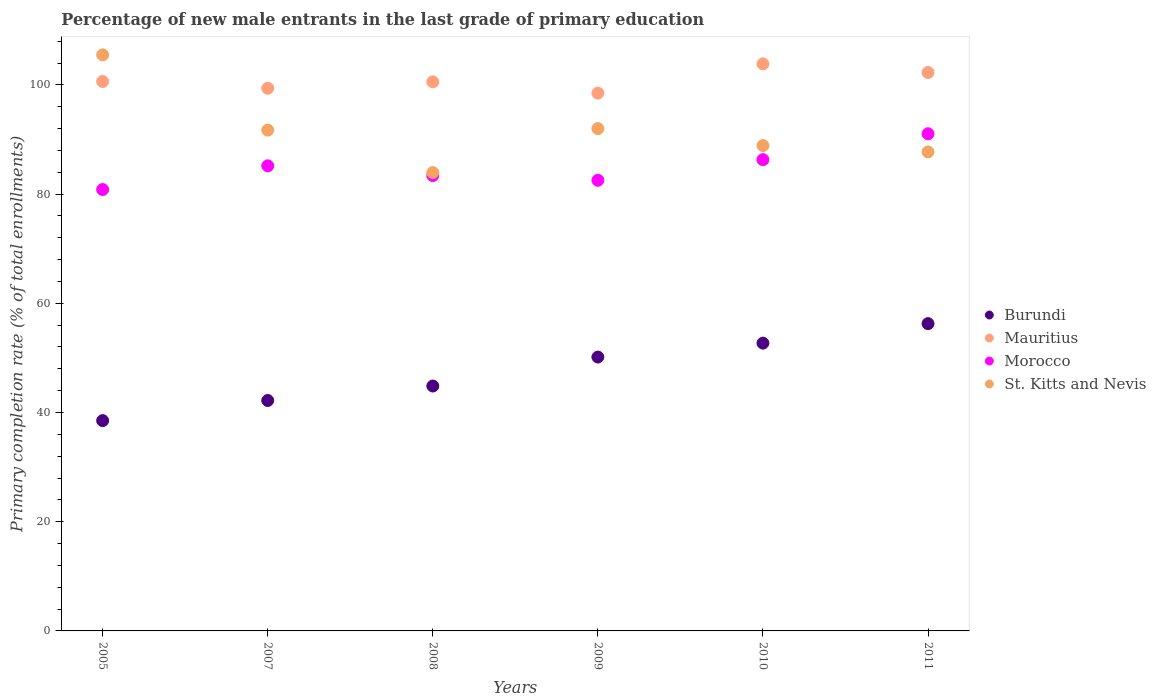Is the number of dotlines equal to the number of legend labels?
Keep it short and to the point. Yes. What is the percentage of new male entrants in Morocco in 2009?
Your answer should be very brief. 82.53. Across all years, what is the maximum percentage of new male entrants in St. Kitts and Nevis?
Offer a terse response. 105.5. Across all years, what is the minimum percentage of new male entrants in Burundi?
Give a very brief answer. 38.52. In which year was the percentage of new male entrants in Morocco minimum?
Ensure brevity in your answer.  2005. What is the total percentage of new male entrants in St. Kitts and Nevis in the graph?
Ensure brevity in your answer.  549.79. What is the difference between the percentage of new male entrants in Mauritius in 2005 and that in 2008?
Provide a short and direct response. 0.06. What is the difference between the percentage of new male entrants in Morocco in 2009 and the percentage of new male entrants in Mauritius in 2007?
Offer a very short reply. -16.86. What is the average percentage of new male entrants in Mauritius per year?
Your answer should be compact. 100.87. In the year 2011, what is the difference between the percentage of new male entrants in Morocco and percentage of new male entrants in Mauritius?
Offer a terse response. -11.22. In how many years, is the percentage of new male entrants in Mauritius greater than 44 %?
Provide a succinct answer. 6. What is the ratio of the percentage of new male entrants in Burundi in 2008 to that in 2011?
Keep it short and to the point. 0.8. Is the percentage of new male entrants in Burundi in 2005 less than that in 2011?
Provide a succinct answer. Yes. What is the difference between the highest and the second highest percentage of new male entrants in Mauritius?
Provide a succinct answer. 1.58. What is the difference between the highest and the lowest percentage of new male entrants in St. Kitts and Nevis?
Offer a very short reply. 21.56. In how many years, is the percentage of new male entrants in Burundi greater than the average percentage of new male entrants in Burundi taken over all years?
Your response must be concise. 3. Is it the case that in every year, the sum of the percentage of new male entrants in Morocco and percentage of new male entrants in St. Kitts and Nevis  is greater than the percentage of new male entrants in Mauritius?
Give a very brief answer. Yes. How many dotlines are there?
Provide a short and direct response. 4. How many years are there in the graph?
Provide a short and direct response. 6. Are the values on the major ticks of Y-axis written in scientific E-notation?
Your response must be concise. No. Does the graph contain any zero values?
Offer a very short reply. No. Does the graph contain grids?
Offer a terse response. No. Where does the legend appear in the graph?
Offer a terse response. Center right. What is the title of the graph?
Offer a terse response. Percentage of new male entrants in the last grade of primary education. Does "South Africa" appear as one of the legend labels in the graph?
Provide a succinct answer. No. What is the label or title of the X-axis?
Your answer should be compact. Years. What is the label or title of the Y-axis?
Your answer should be very brief. Primary completion rate (% of total enrollments). What is the Primary completion rate (% of total enrollments) in Burundi in 2005?
Your response must be concise. 38.52. What is the Primary completion rate (% of total enrollments) of Mauritius in 2005?
Provide a short and direct response. 100.62. What is the Primary completion rate (% of total enrollments) of Morocco in 2005?
Provide a succinct answer. 80.83. What is the Primary completion rate (% of total enrollments) of St. Kitts and Nevis in 2005?
Offer a terse response. 105.5. What is the Primary completion rate (% of total enrollments) in Burundi in 2007?
Your response must be concise. 42.21. What is the Primary completion rate (% of total enrollments) of Mauritius in 2007?
Provide a succinct answer. 99.39. What is the Primary completion rate (% of total enrollments) in Morocco in 2007?
Your answer should be compact. 85.18. What is the Primary completion rate (% of total enrollments) of St. Kitts and Nevis in 2007?
Your answer should be very brief. 91.72. What is the Primary completion rate (% of total enrollments) in Burundi in 2008?
Make the answer very short. 44.85. What is the Primary completion rate (% of total enrollments) of Mauritius in 2008?
Your answer should be very brief. 100.57. What is the Primary completion rate (% of total enrollments) in Morocco in 2008?
Provide a short and direct response. 83.4. What is the Primary completion rate (% of total enrollments) in St. Kitts and Nevis in 2008?
Offer a terse response. 83.95. What is the Primary completion rate (% of total enrollments) of Burundi in 2009?
Your answer should be compact. 50.16. What is the Primary completion rate (% of total enrollments) in Mauritius in 2009?
Give a very brief answer. 98.5. What is the Primary completion rate (% of total enrollments) in Morocco in 2009?
Ensure brevity in your answer.  82.53. What is the Primary completion rate (% of total enrollments) in St. Kitts and Nevis in 2009?
Give a very brief answer. 92. What is the Primary completion rate (% of total enrollments) in Burundi in 2010?
Ensure brevity in your answer.  52.71. What is the Primary completion rate (% of total enrollments) of Mauritius in 2010?
Your answer should be compact. 103.86. What is the Primary completion rate (% of total enrollments) of Morocco in 2010?
Provide a short and direct response. 86.31. What is the Primary completion rate (% of total enrollments) in St. Kitts and Nevis in 2010?
Keep it short and to the point. 88.89. What is the Primary completion rate (% of total enrollments) of Burundi in 2011?
Make the answer very short. 56.28. What is the Primary completion rate (% of total enrollments) of Mauritius in 2011?
Provide a succinct answer. 102.27. What is the Primary completion rate (% of total enrollments) of Morocco in 2011?
Your answer should be very brief. 91.05. What is the Primary completion rate (% of total enrollments) in St. Kitts and Nevis in 2011?
Provide a short and direct response. 87.73. Across all years, what is the maximum Primary completion rate (% of total enrollments) of Burundi?
Offer a very short reply. 56.28. Across all years, what is the maximum Primary completion rate (% of total enrollments) in Mauritius?
Your response must be concise. 103.86. Across all years, what is the maximum Primary completion rate (% of total enrollments) of Morocco?
Offer a very short reply. 91.05. Across all years, what is the maximum Primary completion rate (% of total enrollments) of St. Kitts and Nevis?
Your answer should be compact. 105.5. Across all years, what is the minimum Primary completion rate (% of total enrollments) in Burundi?
Offer a very short reply. 38.52. Across all years, what is the minimum Primary completion rate (% of total enrollments) in Mauritius?
Your answer should be very brief. 98.5. Across all years, what is the minimum Primary completion rate (% of total enrollments) of Morocco?
Your answer should be compact. 80.83. Across all years, what is the minimum Primary completion rate (% of total enrollments) of St. Kitts and Nevis?
Keep it short and to the point. 83.95. What is the total Primary completion rate (% of total enrollments) in Burundi in the graph?
Your response must be concise. 284.72. What is the total Primary completion rate (% of total enrollments) of Mauritius in the graph?
Provide a short and direct response. 605.21. What is the total Primary completion rate (% of total enrollments) in Morocco in the graph?
Provide a succinct answer. 509.3. What is the total Primary completion rate (% of total enrollments) in St. Kitts and Nevis in the graph?
Give a very brief answer. 549.79. What is the difference between the Primary completion rate (% of total enrollments) in Burundi in 2005 and that in 2007?
Your response must be concise. -3.69. What is the difference between the Primary completion rate (% of total enrollments) of Mauritius in 2005 and that in 2007?
Make the answer very short. 1.24. What is the difference between the Primary completion rate (% of total enrollments) of Morocco in 2005 and that in 2007?
Offer a very short reply. -4.35. What is the difference between the Primary completion rate (% of total enrollments) of St. Kitts and Nevis in 2005 and that in 2007?
Offer a terse response. 13.78. What is the difference between the Primary completion rate (% of total enrollments) in Burundi in 2005 and that in 2008?
Provide a short and direct response. -6.33. What is the difference between the Primary completion rate (% of total enrollments) of Mauritius in 2005 and that in 2008?
Provide a short and direct response. 0.06. What is the difference between the Primary completion rate (% of total enrollments) in Morocco in 2005 and that in 2008?
Your answer should be very brief. -2.56. What is the difference between the Primary completion rate (% of total enrollments) in St. Kitts and Nevis in 2005 and that in 2008?
Offer a very short reply. 21.56. What is the difference between the Primary completion rate (% of total enrollments) in Burundi in 2005 and that in 2009?
Provide a short and direct response. -11.64. What is the difference between the Primary completion rate (% of total enrollments) of Mauritius in 2005 and that in 2009?
Your answer should be very brief. 2.13. What is the difference between the Primary completion rate (% of total enrollments) of Morocco in 2005 and that in 2009?
Make the answer very short. -1.69. What is the difference between the Primary completion rate (% of total enrollments) of St. Kitts and Nevis in 2005 and that in 2009?
Offer a very short reply. 13.5. What is the difference between the Primary completion rate (% of total enrollments) in Burundi in 2005 and that in 2010?
Provide a succinct answer. -14.19. What is the difference between the Primary completion rate (% of total enrollments) in Mauritius in 2005 and that in 2010?
Provide a short and direct response. -3.23. What is the difference between the Primary completion rate (% of total enrollments) in Morocco in 2005 and that in 2010?
Your response must be concise. -5.48. What is the difference between the Primary completion rate (% of total enrollments) of St. Kitts and Nevis in 2005 and that in 2010?
Your response must be concise. 16.62. What is the difference between the Primary completion rate (% of total enrollments) in Burundi in 2005 and that in 2011?
Offer a terse response. -17.76. What is the difference between the Primary completion rate (% of total enrollments) in Mauritius in 2005 and that in 2011?
Your answer should be compact. -1.65. What is the difference between the Primary completion rate (% of total enrollments) of Morocco in 2005 and that in 2011?
Keep it short and to the point. -10.22. What is the difference between the Primary completion rate (% of total enrollments) in St. Kitts and Nevis in 2005 and that in 2011?
Keep it short and to the point. 17.77. What is the difference between the Primary completion rate (% of total enrollments) of Burundi in 2007 and that in 2008?
Provide a short and direct response. -2.65. What is the difference between the Primary completion rate (% of total enrollments) of Mauritius in 2007 and that in 2008?
Offer a terse response. -1.18. What is the difference between the Primary completion rate (% of total enrollments) of Morocco in 2007 and that in 2008?
Provide a short and direct response. 1.79. What is the difference between the Primary completion rate (% of total enrollments) in St. Kitts and Nevis in 2007 and that in 2008?
Ensure brevity in your answer.  7.77. What is the difference between the Primary completion rate (% of total enrollments) of Burundi in 2007 and that in 2009?
Provide a succinct answer. -7.95. What is the difference between the Primary completion rate (% of total enrollments) of Mauritius in 2007 and that in 2009?
Keep it short and to the point. 0.89. What is the difference between the Primary completion rate (% of total enrollments) of Morocco in 2007 and that in 2009?
Provide a succinct answer. 2.65. What is the difference between the Primary completion rate (% of total enrollments) in St. Kitts and Nevis in 2007 and that in 2009?
Your answer should be very brief. -0.28. What is the difference between the Primary completion rate (% of total enrollments) in Burundi in 2007 and that in 2010?
Provide a succinct answer. -10.5. What is the difference between the Primary completion rate (% of total enrollments) of Mauritius in 2007 and that in 2010?
Provide a succinct answer. -4.47. What is the difference between the Primary completion rate (% of total enrollments) in Morocco in 2007 and that in 2010?
Your response must be concise. -1.13. What is the difference between the Primary completion rate (% of total enrollments) of St. Kitts and Nevis in 2007 and that in 2010?
Keep it short and to the point. 2.83. What is the difference between the Primary completion rate (% of total enrollments) of Burundi in 2007 and that in 2011?
Your answer should be compact. -14.07. What is the difference between the Primary completion rate (% of total enrollments) of Mauritius in 2007 and that in 2011?
Your answer should be very brief. -2.89. What is the difference between the Primary completion rate (% of total enrollments) in Morocco in 2007 and that in 2011?
Offer a very short reply. -5.87. What is the difference between the Primary completion rate (% of total enrollments) in St. Kitts and Nevis in 2007 and that in 2011?
Provide a succinct answer. 3.99. What is the difference between the Primary completion rate (% of total enrollments) in Burundi in 2008 and that in 2009?
Your answer should be compact. -5.3. What is the difference between the Primary completion rate (% of total enrollments) in Mauritius in 2008 and that in 2009?
Offer a terse response. 2.07. What is the difference between the Primary completion rate (% of total enrollments) of Morocco in 2008 and that in 2009?
Your response must be concise. 0.87. What is the difference between the Primary completion rate (% of total enrollments) of St. Kitts and Nevis in 2008 and that in 2009?
Make the answer very short. -8.05. What is the difference between the Primary completion rate (% of total enrollments) of Burundi in 2008 and that in 2010?
Your answer should be compact. -7.85. What is the difference between the Primary completion rate (% of total enrollments) in Mauritius in 2008 and that in 2010?
Offer a very short reply. -3.29. What is the difference between the Primary completion rate (% of total enrollments) of Morocco in 2008 and that in 2010?
Give a very brief answer. -2.92. What is the difference between the Primary completion rate (% of total enrollments) of St. Kitts and Nevis in 2008 and that in 2010?
Ensure brevity in your answer.  -4.94. What is the difference between the Primary completion rate (% of total enrollments) in Burundi in 2008 and that in 2011?
Keep it short and to the point. -11.42. What is the difference between the Primary completion rate (% of total enrollments) of Mauritius in 2008 and that in 2011?
Ensure brevity in your answer.  -1.71. What is the difference between the Primary completion rate (% of total enrollments) of Morocco in 2008 and that in 2011?
Your answer should be compact. -7.66. What is the difference between the Primary completion rate (% of total enrollments) in St. Kitts and Nevis in 2008 and that in 2011?
Make the answer very short. -3.78. What is the difference between the Primary completion rate (% of total enrollments) in Burundi in 2009 and that in 2010?
Provide a succinct answer. -2.55. What is the difference between the Primary completion rate (% of total enrollments) of Mauritius in 2009 and that in 2010?
Your answer should be compact. -5.36. What is the difference between the Primary completion rate (% of total enrollments) in Morocco in 2009 and that in 2010?
Keep it short and to the point. -3.78. What is the difference between the Primary completion rate (% of total enrollments) in St. Kitts and Nevis in 2009 and that in 2010?
Provide a succinct answer. 3.11. What is the difference between the Primary completion rate (% of total enrollments) in Burundi in 2009 and that in 2011?
Give a very brief answer. -6.12. What is the difference between the Primary completion rate (% of total enrollments) in Mauritius in 2009 and that in 2011?
Offer a terse response. -3.77. What is the difference between the Primary completion rate (% of total enrollments) of Morocco in 2009 and that in 2011?
Your answer should be compact. -8.52. What is the difference between the Primary completion rate (% of total enrollments) of St. Kitts and Nevis in 2009 and that in 2011?
Your answer should be very brief. 4.27. What is the difference between the Primary completion rate (% of total enrollments) in Burundi in 2010 and that in 2011?
Your answer should be compact. -3.57. What is the difference between the Primary completion rate (% of total enrollments) in Mauritius in 2010 and that in 2011?
Make the answer very short. 1.58. What is the difference between the Primary completion rate (% of total enrollments) in Morocco in 2010 and that in 2011?
Keep it short and to the point. -4.74. What is the difference between the Primary completion rate (% of total enrollments) in St. Kitts and Nevis in 2010 and that in 2011?
Make the answer very short. 1.16. What is the difference between the Primary completion rate (% of total enrollments) in Burundi in 2005 and the Primary completion rate (% of total enrollments) in Mauritius in 2007?
Provide a short and direct response. -60.87. What is the difference between the Primary completion rate (% of total enrollments) of Burundi in 2005 and the Primary completion rate (% of total enrollments) of Morocco in 2007?
Make the answer very short. -46.66. What is the difference between the Primary completion rate (% of total enrollments) in Burundi in 2005 and the Primary completion rate (% of total enrollments) in St. Kitts and Nevis in 2007?
Make the answer very short. -53.2. What is the difference between the Primary completion rate (% of total enrollments) in Mauritius in 2005 and the Primary completion rate (% of total enrollments) in Morocco in 2007?
Provide a short and direct response. 15.44. What is the difference between the Primary completion rate (% of total enrollments) of Mauritius in 2005 and the Primary completion rate (% of total enrollments) of St. Kitts and Nevis in 2007?
Provide a short and direct response. 8.9. What is the difference between the Primary completion rate (% of total enrollments) of Morocco in 2005 and the Primary completion rate (% of total enrollments) of St. Kitts and Nevis in 2007?
Make the answer very short. -10.89. What is the difference between the Primary completion rate (% of total enrollments) in Burundi in 2005 and the Primary completion rate (% of total enrollments) in Mauritius in 2008?
Your answer should be compact. -62.05. What is the difference between the Primary completion rate (% of total enrollments) in Burundi in 2005 and the Primary completion rate (% of total enrollments) in Morocco in 2008?
Provide a succinct answer. -44.88. What is the difference between the Primary completion rate (% of total enrollments) of Burundi in 2005 and the Primary completion rate (% of total enrollments) of St. Kitts and Nevis in 2008?
Your answer should be very brief. -45.43. What is the difference between the Primary completion rate (% of total enrollments) of Mauritius in 2005 and the Primary completion rate (% of total enrollments) of Morocco in 2008?
Provide a short and direct response. 17.23. What is the difference between the Primary completion rate (% of total enrollments) in Mauritius in 2005 and the Primary completion rate (% of total enrollments) in St. Kitts and Nevis in 2008?
Offer a terse response. 16.68. What is the difference between the Primary completion rate (% of total enrollments) in Morocco in 2005 and the Primary completion rate (% of total enrollments) in St. Kitts and Nevis in 2008?
Give a very brief answer. -3.11. What is the difference between the Primary completion rate (% of total enrollments) in Burundi in 2005 and the Primary completion rate (% of total enrollments) in Mauritius in 2009?
Your answer should be very brief. -59.98. What is the difference between the Primary completion rate (% of total enrollments) of Burundi in 2005 and the Primary completion rate (% of total enrollments) of Morocco in 2009?
Ensure brevity in your answer.  -44.01. What is the difference between the Primary completion rate (% of total enrollments) of Burundi in 2005 and the Primary completion rate (% of total enrollments) of St. Kitts and Nevis in 2009?
Ensure brevity in your answer.  -53.48. What is the difference between the Primary completion rate (% of total enrollments) in Mauritius in 2005 and the Primary completion rate (% of total enrollments) in Morocco in 2009?
Make the answer very short. 18.1. What is the difference between the Primary completion rate (% of total enrollments) in Mauritius in 2005 and the Primary completion rate (% of total enrollments) in St. Kitts and Nevis in 2009?
Ensure brevity in your answer.  8.62. What is the difference between the Primary completion rate (% of total enrollments) in Morocco in 2005 and the Primary completion rate (% of total enrollments) in St. Kitts and Nevis in 2009?
Provide a succinct answer. -11.17. What is the difference between the Primary completion rate (% of total enrollments) of Burundi in 2005 and the Primary completion rate (% of total enrollments) of Mauritius in 2010?
Ensure brevity in your answer.  -65.34. What is the difference between the Primary completion rate (% of total enrollments) in Burundi in 2005 and the Primary completion rate (% of total enrollments) in Morocco in 2010?
Ensure brevity in your answer.  -47.79. What is the difference between the Primary completion rate (% of total enrollments) in Burundi in 2005 and the Primary completion rate (% of total enrollments) in St. Kitts and Nevis in 2010?
Provide a short and direct response. -50.37. What is the difference between the Primary completion rate (% of total enrollments) of Mauritius in 2005 and the Primary completion rate (% of total enrollments) of Morocco in 2010?
Ensure brevity in your answer.  14.31. What is the difference between the Primary completion rate (% of total enrollments) in Mauritius in 2005 and the Primary completion rate (% of total enrollments) in St. Kitts and Nevis in 2010?
Offer a very short reply. 11.74. What is the difference between the Primary completion rate (% of total enrollments) in Morocco in 2005 and the Primary completion rate (% of total enrollments) in St. Kitts and Nevis in 2010?
Ensure brevity in your answer.  -8.05. What is the difference between the Primary completion rate (% of total enrollments) in Burundi in 2005 and the Primary completion rate (% of total enrollments) in Mauritius in 2011?
Your answer should be compact. -63.75. What is the difference between the Primary completion rate (% of total enrollments) of Burundi in 2005 and the Primary completion rate (% of total enrollments) of Morocco in 2011?
Offer a very short reply. -52.53. What is the difference between the Primary completion rate (% of total enrollments) of Burundi in 2005 and the Primary completion rate (% of total enrollments) of St. Kitts and Nevis in 2011?
Offer a terse response. -49.21. What is the difference between the Primary completion rate (% of total enrollments) of Mauritius in 2005 and the Primary completion rate (% of total enrollments) of Morocco in 2011?
Offer a terse response. 9.57. What is the difference between the Primary completion rate (% of total enrollments) of Mauritius in 2005 and the Primary completion rate (% of total enrollments) of St. Kitts and Nevis in 2011?
Your response must be concise. 12.89. What is the difference between the Primary completion rate (% of total enrollments) in Morocco in 2005 and the Primary completion rate (% of total enrollments) in St. Kitts and Nevis in 2011?
Your response must be concise. -6.9. What is the difference between the Primary completion rate (% of total enrollments) in Burundi in 2007 and the Primary completion rate (% of total enrollments) in Mauritius in 2008?
Make the answer very short. -58.36. What is the difference between the Primary completion rate (% of total enrollments) in Burundi in 2007 and the Primary completion rate (% of total enrollments) in Morocco in 2008?
Give a very brief answer. -41.19. What is the difference between the Primary completion rate (% of total enrollments) of Burundi in 2007 and the Primary completion rate (% of total enrollments) of St. Kitts and Nevis in 2008?
Your response must be concise. -41.74. What is the difference between the Primary completion rate (% of total enrollments) of Mauritius in 2007 and the Primary completion rate (% of total enrollments) of Morocco in 2008?
Your response must be concise. 15.99. What is the difference between the Primary completion rate (% of total enrollments) of Mauritius in 2007 and the Primary completion rate (% of total enrollments) of St. Kitts and Nevis in 2008?
Your answer should be very brief. 15.44. What is the difference between the Primary completion rate (% of total enrollments) in Morocco in 2007 and the Primary completion rate (% of total enrollments) in St. Kitts and Nevis in 2008?
Your response must be concise. 1.23. What is the difference between the Primary completion rate (% of total enrollments) of Burundi in 2007 and the Primary completion rate (% of total enrollments) of Mauritius in 2009?
Your answer should be compact. -56.29. What is the difference between the Primary completion rate (% of total enrollments) of Burundi in 2007 and the Primary completion rate (% of total enrollments) of Morocco in 2009?
Give a very brief answer. -40.32. What is the difference between the Primary completion rate (% of total enrollments) in Burundi in 2007 and the Primary completion rate (% of total enrollments) in St. Kitts and Nevis in 2009?
Offer a terse response. -49.8. What is the difference between the Primary completion rate (% of total enrollments) in Mauritius in 2007 and the Primary completion rate (% of total enrollments) in Morocco in 2009?
Offer a terse response. 16.86. What is the difference between the Primary completion rate (% of total enrollments) in Mauritius in 2007 and the Primary completion rate (% of total enrollments) in St. Kitts and Nevis in 2009?
Your answer should be very brief. 7.39. What is the difference between the Primary completion rate (% of total enrollments) in Morocco in 2007 and the Primary completion rate (% of total enrollments) in St. Kitts and Nevis in 2009?
Your answer should be compact. -6.82. What is the difference between the Primary completion rate (% of total enrollments) of Burundi in 2007 and the Primary completion rate (% of total enrollments) of Mauritius in 2010?
Your answer should be very brief. -61.65. What is the difference between the Primary completion rate (% of total enrollments) of Burundi in 2007 and the Primary completion rate (% of total enrollments) of Morocco in 2010?
Ensure brevity in your answer.  -44.11. What is the difference between the Primary completion rate (% of total enrollments) in Burundi in 2007 and the Primary completion rate (% of total enrollments) in St. Kitts and Nevis in 2010?
Give a very brief answer. -46.68. What is the difference between the Primary completion rate (% of total enrollments) in Mauritius in 2007 and the Primary completion rate (% of total enrollments) in Morocco in 2010?
Offer a terse response. 13.07. What is the difference between the Primary completion rate (% of total enrollments) in Mauritius in 2007 and the Primary completion rate (% of total enrollments) in St. Kitts and Nevis in 2010?
Ensure brevity in your answer.  10.5. What is the difference between the Primary completion rate (% of total enrollments) of Morocco in 2007 and the Primary completion rate (% of total enrollments) of St. Kitts and Nevis in 2010?
Keep it short and to the point. -3.71. What is the difference between the Primary completion rate (% of total enrollments) of Burundi in 2007 and the Primary completion rate (% of total enrollments) of Mauritius in 2011?
Provide a succinct answer. -60.07. What is the difference between the Primary completion rate (% of total enrollments) of Burundi in 2007 and the Primary completion rate (% of total enrollments) of Morocco in 2011?
Offer a very short reply. -48.85. What is the difference between the Primary completion rate (% of total enrollments) of Burundi in 2007 and the Primary completion rate (% of total enrollments) of St. Kitts and Nevis in 2011?
Give a very brief answer. -45.52. What is the difference between the Primary completion rate (% of total enrollments) of Mauritius in 2007 and the Primary completion rate (% of total enrollments) of Morocco in 2011?
Keep it short and to the point. 8.33. What is the difference between the Primary completion rate (% of total enrollments) in Mauritius in 2007 and the Primary completion rate (% of total enrollments) in St. Kitts and Nevis in 2011?
Provide a succinct answer. 11.66. What is the difference between the Primary completion rate (% of total enrollments) of Morocco in 2007 and the Primary completion rate (% of total enrollments) of St. Kitts and Nevis in 2011?
Your answer should be very brief. -2.55. What is the difference between the Primary completion rate (% of total enrollments) in Burundi in 2008 and the Primary completion rate (% of total enrollments) in Mauritius in 2009?
Offer a terse response. -53.65. What is the difference between the Primary completion rate (% of total enrollments) in Burundi in 2008 and the Primary completion rate (% of total enrollments) in Morocco in 2009?
Provide a short and direct response. -37.68. What is the difference between the Primary completion rate (% of total enrollments) in Burundi in 2008 and the Primary completion rate (% of total enrollments) in St. Kitts and Nevis in 2009?
Offer a terse response. -47.15. What is the difference between the Primary completion rate (% of total enrollments) in Mauritius in 2008 and the Primary completion rate (% of total enrollments) in Morocco in 2009?
Offer a terse response. 18.04. What is the difference between the Primary completion rate (% of total enrollments) of Mauritius in 2008 and the Primary completion rate (% of total enrollments) of St. Kitts and Nevis in 2009?
Offer a terse response. 8.57. What is the difference between the Primary completion rate (% of total enrollments) in Morocco in 2008 and the Primary completion rate (% of total enrollments) in St. Kitts and Nevis in 2009?
Your answer should be compact. -8.6. What is the difference between the Primary completion rate (% of total enrollments) of Burundi in 2008 and the Primary completion rate (% of total enrollments) of Mauritius in 2010?
Your answer should be very brief. -59. What is the difference between the Primary completion rate (% of total enrollments) of Burundi in 2008 and the Primary completion rate (% of total enrollments) of Morocco in 2010?
Offer a very short reply. -41.46. What is the difference between the Primary completion rate (% of total enrollments) in Burundi in 2008 and the Primary completion rate (% of total enrollments) in St. Kitts and Nevis in 2010?
Make the answer very short. -44.04. What is the difference between the Primary completion rate (% of total enrollments) of Mauritius in 2008 and the Primary completion rate (% of total enrollments) of Morocco in 2010?
Offer a very short reply. 14.26. What is the difference between the Primary completion rate (% of total enrollments) of Mauritius in 2008 and the Primary completion rate (% of total enrollments) of St. Kitts and Nevis in 2010?
Your answer should be compact. 11.68. What is the difference between the Primary completion rate (% of total enrollments) of Morocco in 2008 and the Primary completion rate (% of total enrollments) of St. Kitts and Nevis in 2010?
Your answer should be very brief. -5.49. What is the difference between the Primary completion rate (% of total enrollments) of Burundi in 2008 and the Primary completion rate (% of total enrollments) of Mauritius in 2011?
Offer a very short reply. -57.42. What is the difference between the Primary completion rate (% of total enrollments) in Burundi in 2008 and the Primary completion rate (% of total enrollments) in Morocco in 2011?
Offer a terse response. -46.2. What is the difference between the Primary completion rate (% of total enrollments) of Burundi in 2008 and the Primary completion rate (% of total enrollments) of St. Kitts and Nevis in 2011?
Give a very brief answer. -42.88. What is the difference between the Primary completion rate (% of total enrollments) in Mauritius in 2008 and the Primary completion rate (% of total enrollments) in Morocco in 2011?
Your answer should be very brief. 9.52. What is the difference between the Primary completion rate (% of total enrollments) of Mauritius in 2008 and the Primary completion rate (% of total enrollments) of St. Kitts and Nevis in 2011?
Provide a short and direct response. 12.84. What is the difference between the Primary completion rate (% of total enrollments) of Morocco in 2008 and the Primary completion rate (% of total enrollments) of St. Kitts and Nevis in 2011?
Keep it short and to the point. -4.33. What is the difference between the Primary completion rate (% of total enrollments) of Burundi in 2009 and the Primary completion rate (% of total enrollments) of Mauritius in 2010?
Provide a short and direct response. -53.7. What is the difference between the Primary completion rate (% of total enrollments) of Burundi in 2009 and the Primary completion rate (% of total enrollments) of Morocco in 2010?
Your answer should be compact. -36.15. What is the difference between the Primary completion rate (% of total enrollments) of Burundi in 2009 and the Primary completion rate (% of total enrollments) of St. Kitts and Nevis in 2010?
Provide a succinct answer. -38.73. What is the difference between the Primary completion rate (% of total enrollments) in Mauritius in 2009 and the Primary completion rate (% of total enrollments) in Morocco in 2010?
Keep it short and to the point. 12.19. What is the difference between the Primary completion rate (% of total enrollments) in Mauritius in 2009 and the Primary completion rate (% of total enrollments) in St. Kitts and Nevis in 2010?
Your answer should be very brief. 9.61. What is the difference between the Primary completion rate (% of total enrollments) in Morocco in 2009 and the Primary completion rate (% of total enrollments) in St. Kitts and Nevis in 2010?
Offer a very short reply. -6.36. What is the difference between the Primary completion rate (% of total enrollments) of Burundi in 2009 and the Primary completion rate (% of total enrollments) of Mauritius in 2011?
Offer a very short reply. -52.12. What is the difference between the Primary completion rate (% of total enrollments) in Burundi in 2009 and the Primary completion rate (% of total enrollments) in Morocco in 2011?
Make the answer very short. -40.9. What is the difference between the Primary completion rate (% of total enrollments) in Burundi in 2009 and the Primary completion rate (% of total enrollments) in St. Kitts and Nevis in 2011?
Make the answer very short. -37.57. What is the difference between the Primary completion rate (% of total enrollments) in Mauritius in 2009 and the Primary completion rate (% of total enrollments) in Morocco in 2011?
Make the answer very short. 7.45. What is the difference between the Primary completion rate (% of total enrollments) of Mauritius in 2009 and the Primary completion rate (% of total enrollments) of St. Kitts and Nevis in 2011?
Provide a succinct answer. 10.77. What is the difference between the Primary completion rate (% of total enrollments) of Morocco in 2009 and the Primary completion rate (% of total enrollments) of St. Kitts and Nevis in 2011?
Provide a succinct answer. -5.2. What is the difference between the Primary completion rate (% of total enrollments) of Burundi in 2010 and the Primary completion rate (% of total enrollments) of Mauritius in 2011?
Provide a succinct answer. -49.57. What is the difference between the Primary completion rate (% of total enrollments) of Burundi in 2010 and the Primary completion rate (% of total enrollments) of Morocco in 2011?
Your answer should be compact. -38.35. What is the difference between the Primary completion rate (% of total enrollments) in Burundi in 2010 and the Primary completion rate (% of total enrollments) in St. Kitts and Nevis in 2011?
Your answer should be compact. -35.02. What is the difference between the Primary completion rate (% of total enrollments) in Mauritius in 2010 and the Primary completion rate (% of total enrollments) in Morocco in 2011?
Provide a succinct answer. 12.8. What is the difference between the Primary completion rate (% of total enrollments) of Mauritius in 2010 and the Primary completion rate (% of total enrollments) of St. Kitts and Nevis in 2011?
Keep it short and to the point. 16.13. What is the difference between the Primary completion rate (% of total enrollments) of Morocco in 2010 and the Primary completion rate (% of total enrollments) of St. Kitts and Nevis in 2011?
Your answer should be very brief. -1.42. What is the average Primary completion rate (% of total enrollments) of Burundi per year?
Ensure brevity in your answer.  47.45. What is the average Primary completion rate (% of total enrollments) in Mauritius per year?
Offer a terse response. 100.87. What is the average Primary completion rate (% of total enrollments) in Morocco per year?
Keep it short and to the point. 84.88. What is the average Primary completion rate (% of total enrollments) of St. Kitts and Nevis per year?
Keep it short and to the point. 91.63. In the year 2005, what is the difference between the Primary completion rate (% of total enrollments) in Burundi and Primary completion rate (% of total enrollments) in Mauritius?
Ensure brevity in your answer.  -62.11. In the year 2005, what is the difference between the Primary completion rate (% of total enrollments) in Burundi and Primary completion rate (% of total enrollments) in Morocco?
Your answer should be compact. -42.32. In the year 2005, what is the difference between the Primary completion rate (% of total enrollments) of Burundi and Primary completion rate (% of total enrollments) of St. Kitts and Nevis?
Your answer should be very brief. -66.99. In the year 2005, what is the difference between the Primary completion rate (% of total enrollments) of Mauritius and Primary completion rate (% of total enrollments) of Morocco?
Ensure brevity in your answer.  19.79. In the year 2005, what is the difference between the Primary completion rate (% of total enrollments) in Mauritius and Primary completion rate (% of total enrollments) in St. Kitts and Nevis?
Your answer should be very brief. -4.88. In the year 2005, what is the difference between the Primary completion rate (% of total enrollments) in Morocco and Primary completion rate (% of total enrollments) in St. Kitts and Nevis?
Give a very brief answer. -24.67. In the year 2007, what is the difference between the Primary completion rate (% of total enrollments) of Burundi and Primary completion rate (% of total enrollments) of Mauritius?
Provide a short and direct response. -57.18. In the year 2007, what is the difference between the Primary completion rate (% of total enrollments) of Burundi and Primary completion rate (% of total enrollments) of Morocco?
Give a very brief answer. -42.98. In the year 2007, what is the difference between the Primary completion rate (% of total enrollments) of Burundi and Primary completion rate (% of total enrollments) of St. Kitts and Nevis?
Give a very brief answer. -49.52. In the year 2007, what is the difference between the Primary completion rate (% of total enrollments) in Mauritius and Primary completion rate (% of total enrollments) in Morocco?
Offer a very short reply. 14.2. In the year 2007, what is the difference between the Primary completion rate (% of total enrollments) of Mauritius and Primary completion rate (% of total enrollments) of St. Kitts and Nevis?
Provide a succinct answer. 7.66. In the year 2007, what is the difference between the Primary completion rate (% of total enrollments) in Morocco and Primary completion rate (% of total enrollments) in St. Kitts and Nevis?
Your answer should be compact. -6.54. In the year 2008, what is the difference between the Primary completion rate (% of total enrollments) of Burundi and Primary completion rate (% of total enrollments) of Mauritius?
Your answer should be very brief. -55.72. In the year 2008, what is the difference between the Primary completion rate (% of total enrollments) of Burundi and Primary completion rate (% of total enrollments) of Morocco?
Ensure brevity in your answer.  -38.54. In the year 2008, what is the difference between the Primary completion rate (% of total enrollments) of Burundi and Primary completion rate (% of total enrollments) of St. Kitts and Nevis?
Your answer should be very brief. -39.1. In the year 2008, what is the difference between the Primary completion rate (% of total enrollments) in Mauritius and Primary completion rate (% of total enrollments) in Morocco?
Your answer should be very brief. 17.17. In the year 2008, what is the difference between the Primary completion rate (% of total enrollments) of Mauritius and Primary completion rate (% of total enrollments) of St. Kitts and Nevis?
Ensure brevity in your answer.  16.62. In the year 2008, what is the difference between the Primary completion rate (% of total enrollments) in Morocco and Primary completion rate (% of total enrollments) in St. Kitts and Nevis?
Your answer should be compact. -0.55. In the year 2009, what is the difference between the Primary completion rate (% of total enrollments) of Burundi and Primary completion rate (% of total enrollments) of Mauritius?
Make the answer very short. -48.34. In the year 2009, what is the difference between the Primary completion rate (% of total enrollments) in Burundi and Primary completion rate (% of total enrollments) in Morocco?
Keep it short and to the point. -32.37. In the year 2009, what is the difference between the Primary completion rate (% of total enrollments) of Burundi and Primary completion rate (% of total enrollments) of St. Kitts and Nevis?
Offer a very short reply. -41.84. In the year 2009, what is the difference between the Primary completion rate (% of total enrollments) in Mauritius and Primary completion rate (% of total enrollments) in Morocco?
Make the answer very short. 15.97. In the year 2009, what is the difference between the Primary completion rate (% of total enrollments) in Mauritius and Primary completion rate (% of total enrollments) in St. Kitts and Nevis?
Your answer should be compact. 6.5. In the year 2009, what is the difference between the Primary completion rate (% of total enrollments) of Morocco and Primary completion rate (% of total enrollments) of St. Kitts and Nevis?
Give a very brief answer. -9.47. In the year 2010, what is the difference between the Primary completion rate (% of total enrollments) of Burundi and Primary completion rate (% of total enrollments) of Mauritius?
Make the answer very short. -51.15. In the year 2010, what is the difference between the Primary completion rate (% of total enrollments) of Burundi and Primary completion rate (% of total enrollments) of Morocco?
Provide a short and direct response. -33.6. In the year 2010, what is the difference between the Primary completion rate (% of total enrollments) in Burundi and Primary completion rate (% of total enrollments) in St. Kitts and Nevis?
Ensure brevity in your answer.  -36.18. In the year 2010, what is the difference between the Primary completion rate (% of total enrollments) in Mauritius and Primary completion rate (% of total enrollments) in Morocco?
Offer a terse response. 17.54. In the year 2010, what is the difference between the Primary completion rate (% of total enrollments) of Mauritius and Primary completion rate (% of total enrollments) of St. Kitts and Nevis?
Give a very brief answer. 14.97. In the year 2010, what is the difference between the Primary completion rate (% of total enrollments) in Morocco and Primary completion rate (% of total enrollments) in St. Kitts and Nevis?
Provide a succinct answer. -2.58. In the year 2011, what is the difference between the Primary completion rate (% of total enrollments) of Burundi and Primary completion rate (% of total enrollments) of Mauritius?
Your response must be concise. -46. In the year 2011, what is the difference between the Primary completion rate (% of total enrollments) of Burundi and Primary completion rate (% of total enrollments) of Morocco?
Your answer should be very brief. -34.78. In the year 2011, what is the difference between the Primary completion rate (% of total enrollments) in Burundi and Primary completion rate (% of total enrollments) in St. Kitts and Nevis?
Your response must be concise. -31.45. In the year 2011, what is the difference between the Primary completion rate (% of total enrollments) of Mauritius and Primary completion rate (% of total enrollments) of Morocco?
Provide a short and direct response. 11.22. In the year 2011, what is the difference between the Primary completion rate (% of total enrollments) in Mauritius and Primary completion rate (% of total enrollments) in St. Kitts and Nevis?
Provide a short and direct response. 14.54. In the year 2011, what is the difference between the Primary completion rate (% of total enrollments) in Morocco and Primary completion rate (% of total enrollments) in St. Kitts and Nevis?
Offer a terse response. 3.32. What is the ratio of the Primary completion rate (% of total enrollments) in Burundi in 2005 to that in 2007?
Your answer should be compact. 0.91. What is the ratio of the Primary completion rate (% of total enrollments) of Mauritius in 2005 to that in 2007?
Give a very brief answer. 1.01. What is the ratio of the Primary completion rate (% of total enrollments) of Morocco in 2005 to that in 2007?
Keep it short and to the point. 0.95. What is the ratio of the Primary completion rate (% of total enrollments) in St. Kitts and Nevis in 2005 to that in 2007?
Your answer should be very brief. 1.15. What is the ratio of the Primary completion rate (% of total enrollments) in Burundi in 2005 to that in 2008?
Provide a short and direct response. 0.86. What is the ratio of the Primary completion rate (% of total enrollments) of Mauritius in 2005 to that in 2008?
Provide a short and direct response. 1. What is the ratio of the Primary completion rate (% of total enrollments) in Morocco in 2005 to that in 2008?
Your answer should be very brief. 0.97. What is the ratio of the Primary completion rate (% of total enrollments) in St. Kitts and Nevis in 2005 to that in 2008?
Ensure brevity in your answer.  1.26. What is the ratio of the Primary completion rate (% of total enrollments) in Burundi in 2005 to that in 2009?
Your answer should be compact. 0.77. What is the ratio of the Primary completion rate (% of total enrollments) in Mauritius in 2005 to that in 2009?
Give a very brief answer. 1.02. What is the ratio of the Primary completion rate (% of total enrollments) in Morocco in 2005 to that in 2009?
Give a very brief answer. 0.98. What is the ratio of the Primary completion rate (% of total enrollments) in St. Kitts and Nevis in 2005 to that in 2009?
Ensure brevity in your answer.  1.15. What is the ratio of the Primary completion rate (% of total enrollments) of Burundi in 2005 to that in 2010?
Your answer should be very brief. 0.73. What is the ratio of the Primary completion rate (% of total enrollments) in Mauritius in 2005 to that in 2010?
Keep it short and to the point. 0.97. What is the ratio of the Primary completion rate (% of total enrollments) of Morocco in 2005 to that in 2010?
Provide a short and direct response. 0.94. What is the ratio of the Primary completion rate (% of total enrollments) of St. Kitts and Nevis in 2005 to that in 2010?
Provide a succinct answer. 1.19. What is the ratio of the Primary completion rate (% of total enrollments) of Burundi in 2005 to that in 2011?
Give a very brief answer. 0.68. What is the ratio of the Primary completion rate (% of total enrollments) of Mauritius in 2005 to that in 2011?
Make the answer very short. 0.98. What is the ratio of the Primary completion rate (% of total enrollments) of Morocco in 2005 to that in 2011?
Provide a succinct answer. 0.89. What is the ratio of the Primary completion rate (% of total enrollments) in St. Kitts and Nevis in 2005 to that in 2011?
Your response must be concise. 1.2. What is the ratio of the Primary completion rate (% of total enrollments) of Burundi in 2007 to that in 2008?
Your answer should be very brief. 0.94. What is the ratio of the Primary completion rate (% of total enrollments) of Mauritius in 2007 to that in 2008?
Offer a terse response. 0.99. What is the ratio of the Primary completion rate (% of total enrollments) in Morocco in 2007 to that in 2008?
Provide a succinct answer. 1.02. What is the ratio of the Primary completion rate (% of total enrollments) of St. Kitts and Nevis in 2007 to that in 2008?
Provide a succinct answer. 1.09. What is the ratio of the Primary completion rate (% of total enrollments) in Burundi in 2007 to that in 2009?
Your response must be concise. 0.84. What is the ratio of the Primary completion rate (% of total enrollments) in Morocco in 2007 to that in 2009?
Your answer should be compact. 1.03. What is the ratio of the Primary completion rate (% of total enrollments) in St. Kitts and Nevis in 2007 to that in 2009?
Provide a succinct answer. 1. What is the ratio of the Primary completion rate (% of total enrollments) in Burundi in 2007 to that in 2010?
Your response must be concise. 0.8. What is the ratio of the Primary completion rate (% of total enrollments) of Morocco in 2007 to that in 2010?
Your answer should be very brief. 0.99. What is the ratio of the Primary completion rate (% of total enrollments) in St. Kitts and Nevis in 2007 to that in 2010?
Keep it short and to the point. 1.03. What is the ratio of the Primary completion rate (% of total enrollments) in Burundi in 2007 to that in 2011?
Offer a terse response. 0.75. What is the ratio of the Primary completion rate (% of total enrollments) of Mauritius in 2007 to that in 2011?
Ensure brevity in your answer.  0.97. What is the ratio of the Primary completion rate (% of total enrollments) in Morocco in 2007 to that in 2011?
Provide a short and direct response. 0.94. What is the ratio of the Primary completion rate (% of total enrollments) of St. Kitts and Nevis in 2007 to that in 2011?
Provide a succinct answer. 1.05. What is the ratio of the Primary completion rate (% of total enrollments) in Burundi in 2008 to that in 2009?
Make the answer very short. 0.89. What is the ratio of the Primary completion rate (% of total enrollments) in Mauritius in 2008 to that in 2009?
Give a very brief answer. 1.02. What is the ratio of the Primary completion rate (% of total enrollments) in Morocco in 2008 to that in 2009?
Keep it short and to the point. 1.01. What is the ratio of the Primary completion rate (% of total enrollments) of St. Kitts and Nevis in 2008 to that in 2009?
Keep it short and to the point. 0.91. What is the ratio of the Primary completion rate (% of total enrollments) of Burundi in 2008 to that in 2010?
Keep it short and to the point. 0.85. What is the ratio of the Primary completion rate (% of total enrollments) of Mauritius in 2008 to that in 2010?
Keep it short and to the point. 0.97. What is the ratio of the Primary completion rate (% of total enrollments) of Morocco in 2008 to that in 2010?
Your answer should be compact. 0.97. What is the ratio of the Primary completion rate (% of total enrollments) of St. Kitts and Nevis in 2008 to that in 2010?
Your answer should be very brief. 0.94. What is the ratio of the Primary completion rate (% of total enrollments) of Burundi in 2008 to that in 2011?
Your response must be concise. 0.8. What is the ratio of the Primary completion rate (% of total enrollments) of Mauritius in 2008 to that in 2011?
Keep it short and to the point. 0.98. What is the ratio of the Primary completion rate (% of total enrollments) of Morocco in 2008 to that in 2011?
Keep it short and to the point. 0.92. What is the ratio of the Primary completion rate (% of total enrollments) in St. Kitts and Nevis in 2008 to that in 2011?
Ensure brevity in your answer.  0.96. What is the ratio of the Primary completion rate (% of total enrollments) of Burundi in 2009 to that in 2010?
Make the answer very short. 0.95. What is the ratio of the Primary completion rate (% of total enrollments) in Mauritius in 2009 to that in 2010?
Make the answer very short. 0.95. What is the ratio of the Primary completion rate (% of total enrollments) of Morocco in 2009 to that in 2010?
Keep it short and to the point. 0.96. What is the ratio of the Primary completion rate (% of total enrollments) in St. Kitts and Nevis in 2009 to that in 2010?
Provide a succinct answer. 1.03. What is the ratio of the Primary completion rate (% of total enrollments) in Burundi in 2009 to that in 2011?
Provide a succinct answer. 0.89. What is the ratio of the Primary completion rate (% of total enrollments) of Mauritius in 2009 to that in 2011?
Provide a succinct answer. 0.96. What is the ratio of the Primary completion rate (% of total enrollments) in Morocco in 2009 to that in 2011?
Keep it short and to the point. 0.91. What is the ratio of the Primary completion rate (% of total enrollments) in St. Kitts and Nevis in 2009 to that in 2011?
Keep it short and to the point. 1.05. What is the ratio of the Primary completion rate (% of total enrollments) in Burundi in 2010 to that in 2011?
Ensure brevity in your answer.  0.94. What is the ratio of the Primary completion rate (% of total enrollments) of Mauritius in 2010 to that in 2011?
Make the answer very short. 1.02. What is the ratio of the Primary completion rate (% of total enrollments) of Morocco in 2010 to that in 2011?
Keep it short and to the point. 0.95. What is the ratio of the Primary completion rate (% of total enrollments) of St. Kitts and Nevis in 2010 to that in 2011?
Offer a terse response. 1.01. What is the difference between the highest and the second highest Primary completion rate (% of total enrollments) of Burundi?
Offer a very short reply. 3.57. What is the difference between the highest and the second highest Primary completion rate (% of total enrollments) in Mauritius?
Make the answer very short. 1.58. What is the difference between the highest and the second highest Primary completion rate (% of total enrollments) of Morocco?
Your response must be concise. 4.74. What is the difference between the highest and the second highest Primary completion rate (% of total enrollments) in St. Kitts and Nevis?
Your answer should be compact. 13.5. What is the difference between the highest and the lowest Primary completion rate (% of total enrollments) in Burundi?
Your answer should be compact. 17.76. What is the difference between the highest and the lowest Primary completion rate (% of total enrollments) of Mauritius?
Your answer should be very brief. 5.36. What is the difference between the highest and the lowest Primary completion rate (% of total enrollments) in Morocco?
Ensure brevity in your answer.  10.22. What is the difference between the highest and the lowest Primary completion rate (% of total enrollments) in St. Kitts and Nevis?
Your answer should be compact. 21.56. 